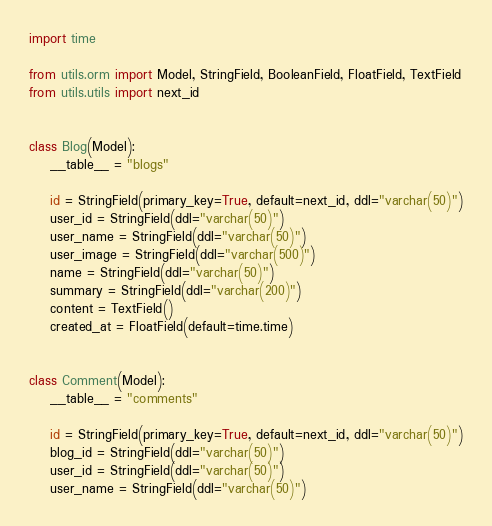Convert code to text. <code><loc_0><loc_0><loc_500><loc_500><_Python_>import time

from utils.orm import Model, StringField, BooleanField, FloatField, TextField
from utils.utils import next_id


class Blog(Model):
    __table__ = "blogs"

    id = StringField(primary_key=True, default=next_id, ddl="varchar(50)")
    user_id = StringField(ddl="varchar(50)")
    user_name = StringField(ddl="varchar(50)")
    user_image = StringField(ddl="varchar(500)")
    name = StringField(ddl="varchar(50)")
    summary = StringField(ddl="varchar(200)")
    content = TextField()
    created_at = FloatField(default=time.time)


class Comment(Model):
    __table__ = "comments"

    id = StringField(primary_key=True, default=next_id, ddl="varchar(50)")
    blog_id = StringField(ddl="varchar(50)")
    user_id = StringField(ddl="varchar(50)")
    user_name = StringField(ddl="varchar(50)")</code> 